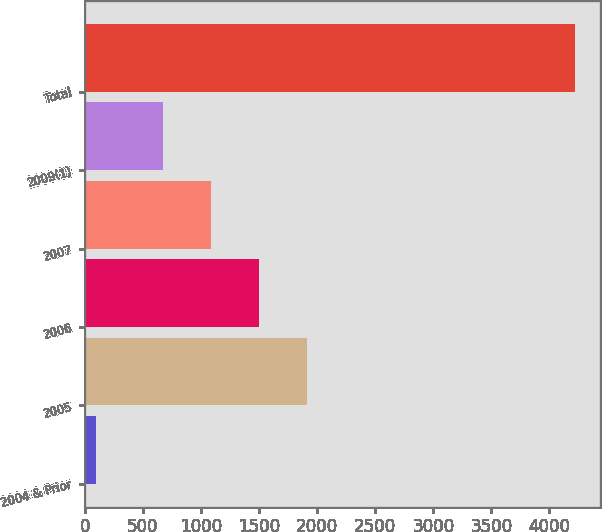Convert chart to OTSL. <chart><loc_0><loc_0><loc_500><loc_500><bar_chart><fcel>2004 & Prior<fcel>2005<fcel>2006<fcel>2007<fcel>2009(1)<fcel>Total<nl><fcel>93<fcel>1909.4<fcel>1496.6<fcel>1083.8<fcel>671<fcel>4221<nl></chart> 